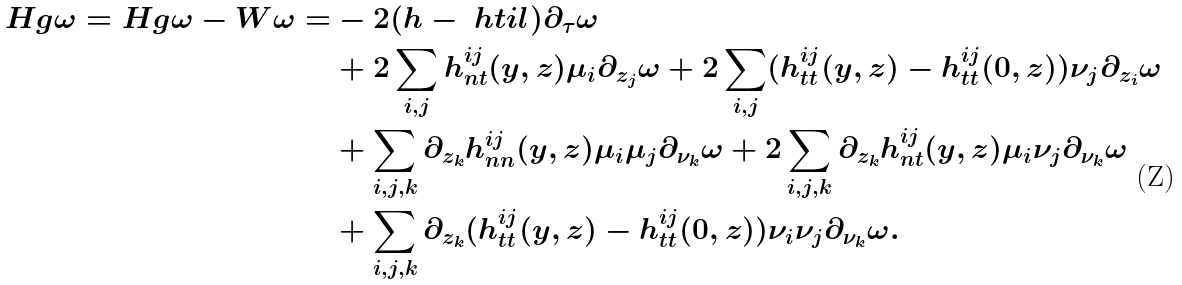<formula> <loc_0><loc_0><loc_500><loc_500>H g \omega = H g \omega - W \omega = & - 2 ( h - \ h t i l ) \partial _ { \tau } \omega \\ & + 2 \sum _ { i , j } h ^ { i j } _ { n t } ( y , z ) \mu _ { i } \partial _ { z _ { j } } \omega + 2 \sum _ { i , j } ( h ^ { i j } _ { t t } ( y , z ) - h ^ { i j } _ { t t } ( 0 , z ) ) \nu _ { j } \partial _ { z _ { i } } \omega \\ & + \sum _ { i , j , k } \partial _ { z _ { k } } h ^ { i j } _ { n n } ( y , z ) \mu _ { i } \mu _ { j } \partial _ { \nu _ { k } } \omega + 2 \sum _ { i , j , k } \partial _ { z _ { k } } h ^ { i j } _ { n t } ( y , z ) \mu _ { i } \nu _ { j } \partial _ { \nu _ { k } } \omega \\ & + \sum _ { i , j , k } \partial _ { z _ { k } } ( h ^ { i j } _ { t t } ( y , z ) - h ^ { i j } _ { t t } ( 0 , z ) ) \nu _ { i } \nu _ { j } \partial _ { \nu _ { k } } \omega .</formula> 